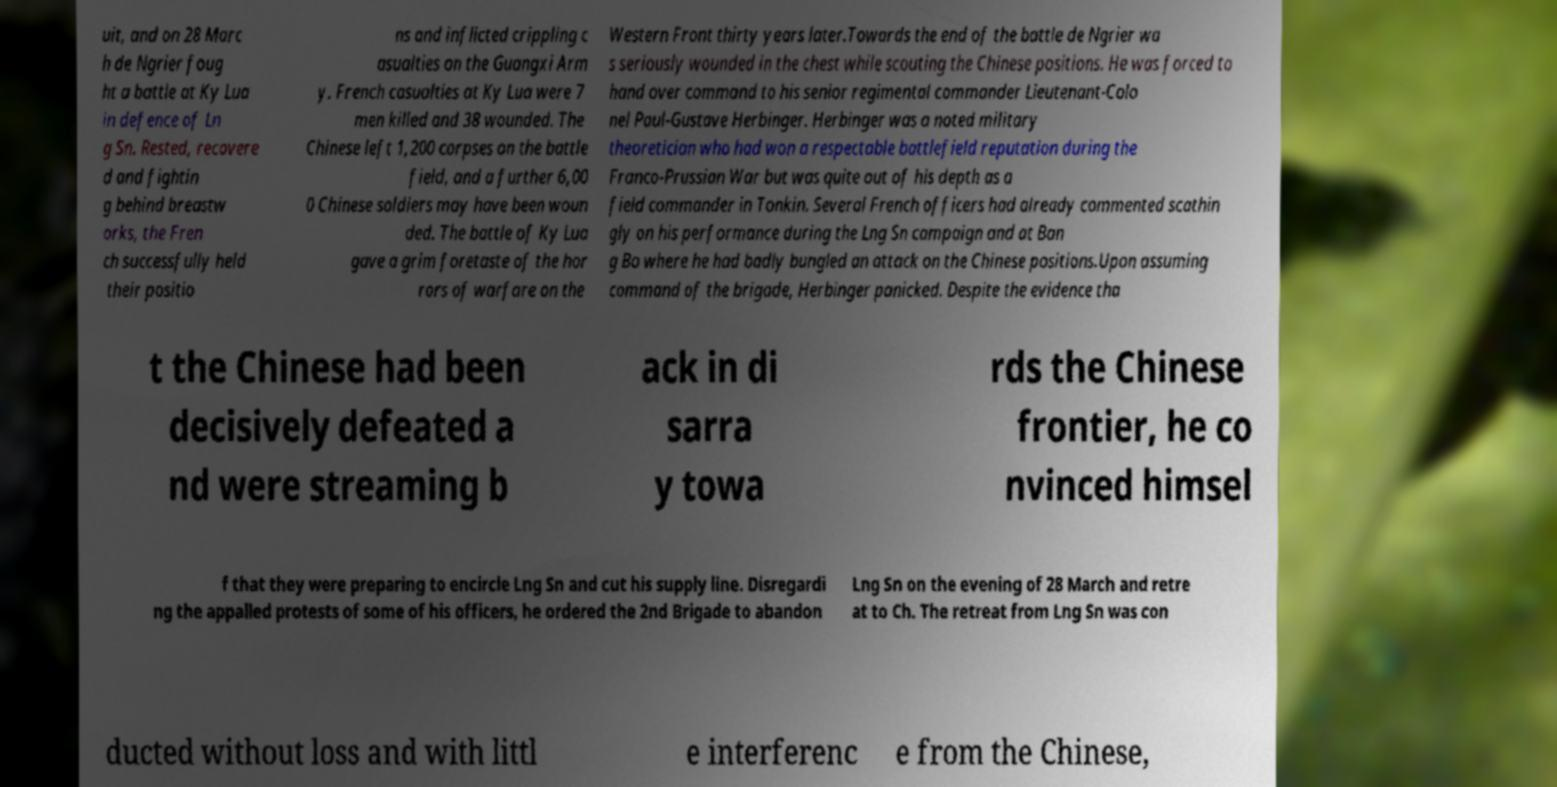Please identify and transcribe the text found in this image. uit, and on 28 Marc h de Ngrier foug ht a battle at Ky Lua in defence of Ln g Sn. Rested, recovere d and fightin g behind breastw orks, the Fren ch successfully held their positio ns and inflicted crippling c asualties on the Guangxi Arm y. French casualties at Ky Lua were 7 men killed and 38 wounded. The Chinese left 1,200 corpses on the battle field, and a further 6,00 0 Chinese soldiers may have been woun ded. The battle of Ky Lua gave a grim foretaste of the hor rors of warfare on the Western Front thirty years later.Towards the end of the battle de Ngrier wa s seriously wounded in the chest while scouting the Chinese positions. He was forced to hand over command to his senior regimental commander Lieutenant-Colo nel Paul-Gustave Herbinger. Herbinger was a noted military theoretician who had won a respectable battlefield reputation during the Franco-Prussian War but was quite out of his depth as a field commander in Tonkin. Several French officers had already commented scathin gly on his performance during the Lng Sn campaign and at Ban g Bo where he had badly bungled an attack on the Chinese positions.Upon assuming command of the brigade, Herbinger panicked. Despite the evidence tha t the Chinese had been decisively defeated a nd were streaming b ack in di sarra y towa rds the Chinese frontier, he co nvinced himsel f that they were preparing to encircle Lng Sn and cut his supply line. Disregardi ng the appalled protests of some of his officers, he ordered the 2nd Brigade to abandon Lng Sn on the evening of 28 March and retre at to Ch. The retreat from Lng Sn was con ducted without loss and with littl e interferenc e from the Chinese, 